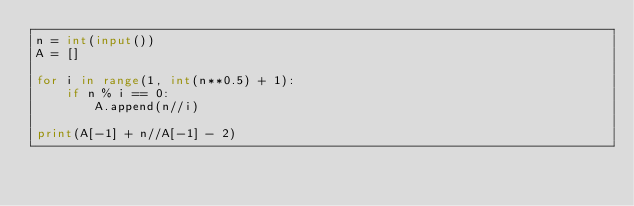<code> <loc_0><loc_0><loc_500><loc_500><_Python_>n = int(input())
A = []

for i in range(1, int(n**0.5) + 1):
    if n % i == 0:
        A.append(n//i)

print(A[-1] + n//A[-1] - 2)</code> 